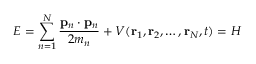Convert formula to latex. <formula><loc_0><loc_0><loc_500><loc_500>E = \sum _ { n = 1 } ^ { N } { \frac { p _ { n } \cdot p _ { n } } { 2 m _ { n } } } + V ( r _ { 1 } , r _ { 2 } , \dots , r _ { N } , t ) = H \,</formula> 